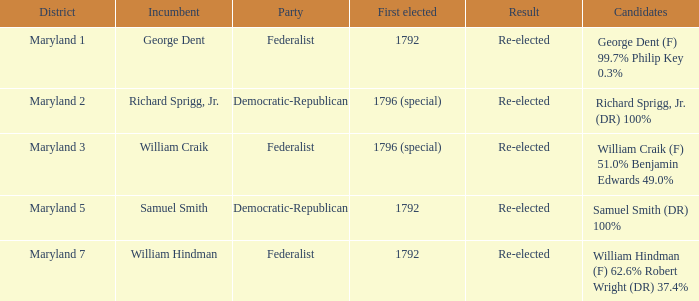Who is the candidates for district maryland 1? George Dent (F) 99.7% Philip Key 0.3%. 